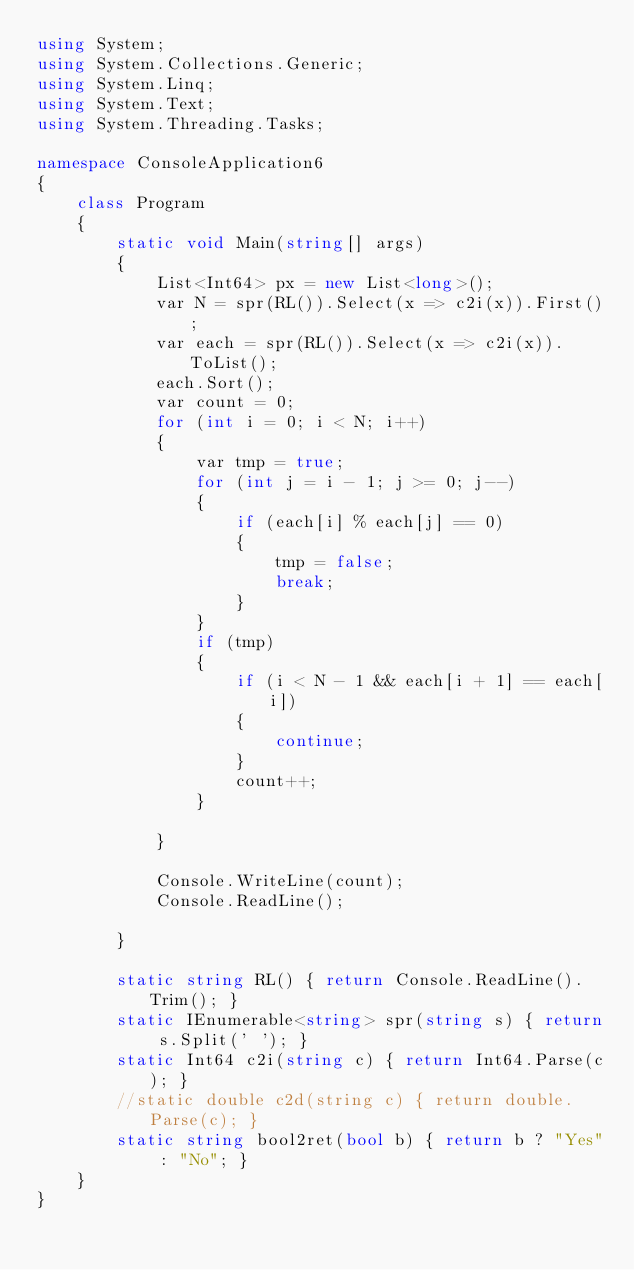<code> <loc_0><loc_0><loc_500><loc_500><_C#_>using System;
using System.Collections.Generic;
using System.Linq;
using System.Text;
using System.Threading.Tasks;

namespace ConsoleApplication6
{
    class Program
    {
        static void Main(string[] args)
        {
            List<Int64> px = new List<long>();
            var N = spr(RL()).Select(x => c2i(x)).First();
            var each = spr(RL()).Select(x => c2i(x)).ToList();
            each.Sort();
            var count = 0;
            for (int i = 0; i < N; i++)
            {
                var tmp = true;
                for (int j = i - 1; j >= 0; j--)
                {
                    if (each[i] % each[j] == 0)
                    {
                        tmp = false;
                        break;
                    }
                }
                if (tmp)
                {
                    if (i < N - 1 && each[i + 1] == each[i])
                    {
                        continue;
                    }
                    count++;
                }

            }
            
            Console.WriteLine(count);
            Console.ReadLine();

        }

        static string RL() { return Console.ReadLine().Trim(); }
        static IEnumerable<string> spr(string s) { return s.Split(' '); }
        static Int64 c2i(string c) { return Int64.Parse(c); }
        //static double c2d(string c) { return double.Parse(c); }
        static string bool2ret(bool b) { return b ? "Yes" : "No"; }
    }
}</code> 